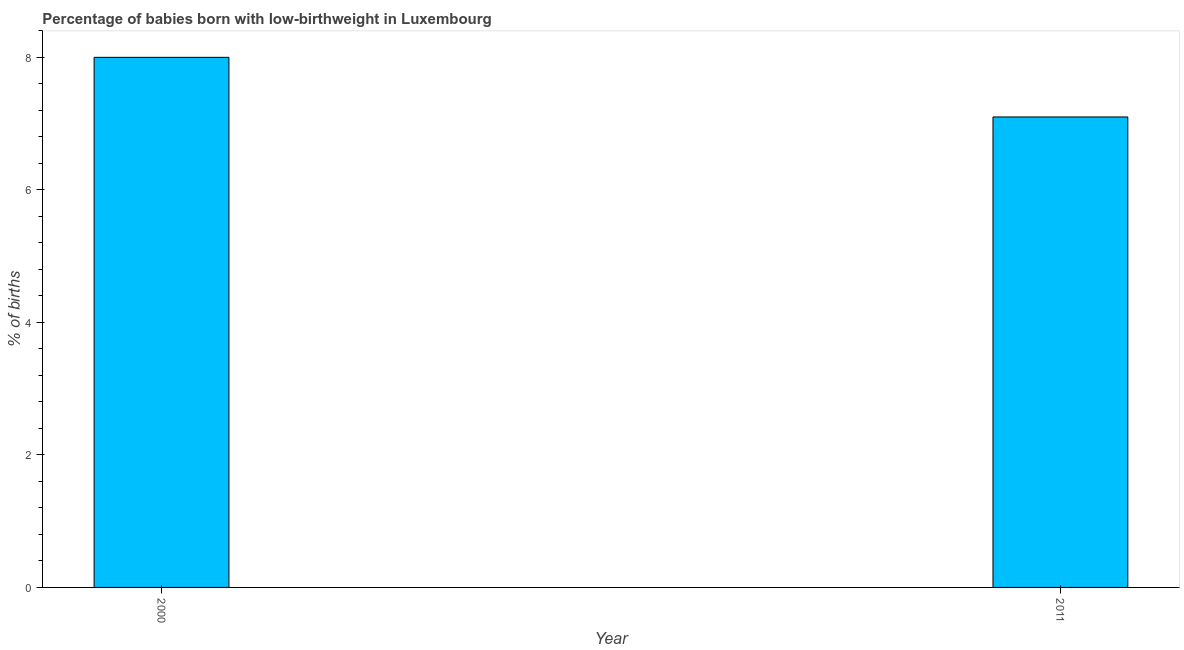Does the graph contain any zero values?
Provide a short and direct response. No. What is the title of the graph?
Provide a short and direct response. Percentage of babies born with low-birthweight in Luxembourg. What is the label or title of the X-axis?
Your response must be concise. Year. What is the label or title of the Y-axis?
Provide a succinct answer. % of births. Across all years, what is the maximum percentage of babies who were born with low-birthweight?
Offer a very short reply. 8. Across all years, what is the minimum percentage of babies who were born with low-birthweight?
Give a very brief answer. 7.1. In which year was the percentage of babies who were born with low-birthweight minimum?
Ensure brevity in your answer.  2011. What is the difference between the percentage of babies who were born with low-birthweight in 2000 and 2011?
Ensure brevity in your answer.  0.9. What is the average percentage of babies who were born with low-birthweight per year?
Offer a very short reply. 7.55. What is the median percentage of babies who were born with low-birthweight?
Your response must be concise. 7.55. Do a majority of the years between 2000 and 2011 (inclusive) have percentage of babies who were born with low-birthweight greater than 1.2 %?
Make the answer very short. Yes. What is the ratio of the percentage of babies who were born with low-birthweight in 2000 to that in 2011?
Your answer should be compact. 1.13. In how many years, is the percentage of babies who were born with low-birthweight greater than the average percentage of babies who were born with low-birthweight taken over all years?
Offer a terse response. 1. How many bars are there?
Offer a terse response. 2. What is the difference between two consecutive major ticks on the Y-axis?
Make the answer very short. 2. What is the % of births in 2000?
Your answer should be compact. 8. What is the % of births in 2011?
Provide a succinct answer. 7.1. What is the ratio of the % of births in 2000 to that in 2011?
Ensure brevity in your answer.  1.13. 